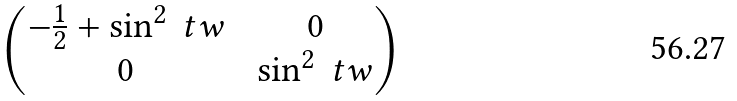<formula> <loc_0><loc_0><loc_500><loc_500>\begin{pmatrix} - \frac { 1 } { 2 } + \sin ^ { 2 } \ t w & & 0 \\ 0 & & \sin ^ { 2 } \ t w \end{pmatrix}</formula> 